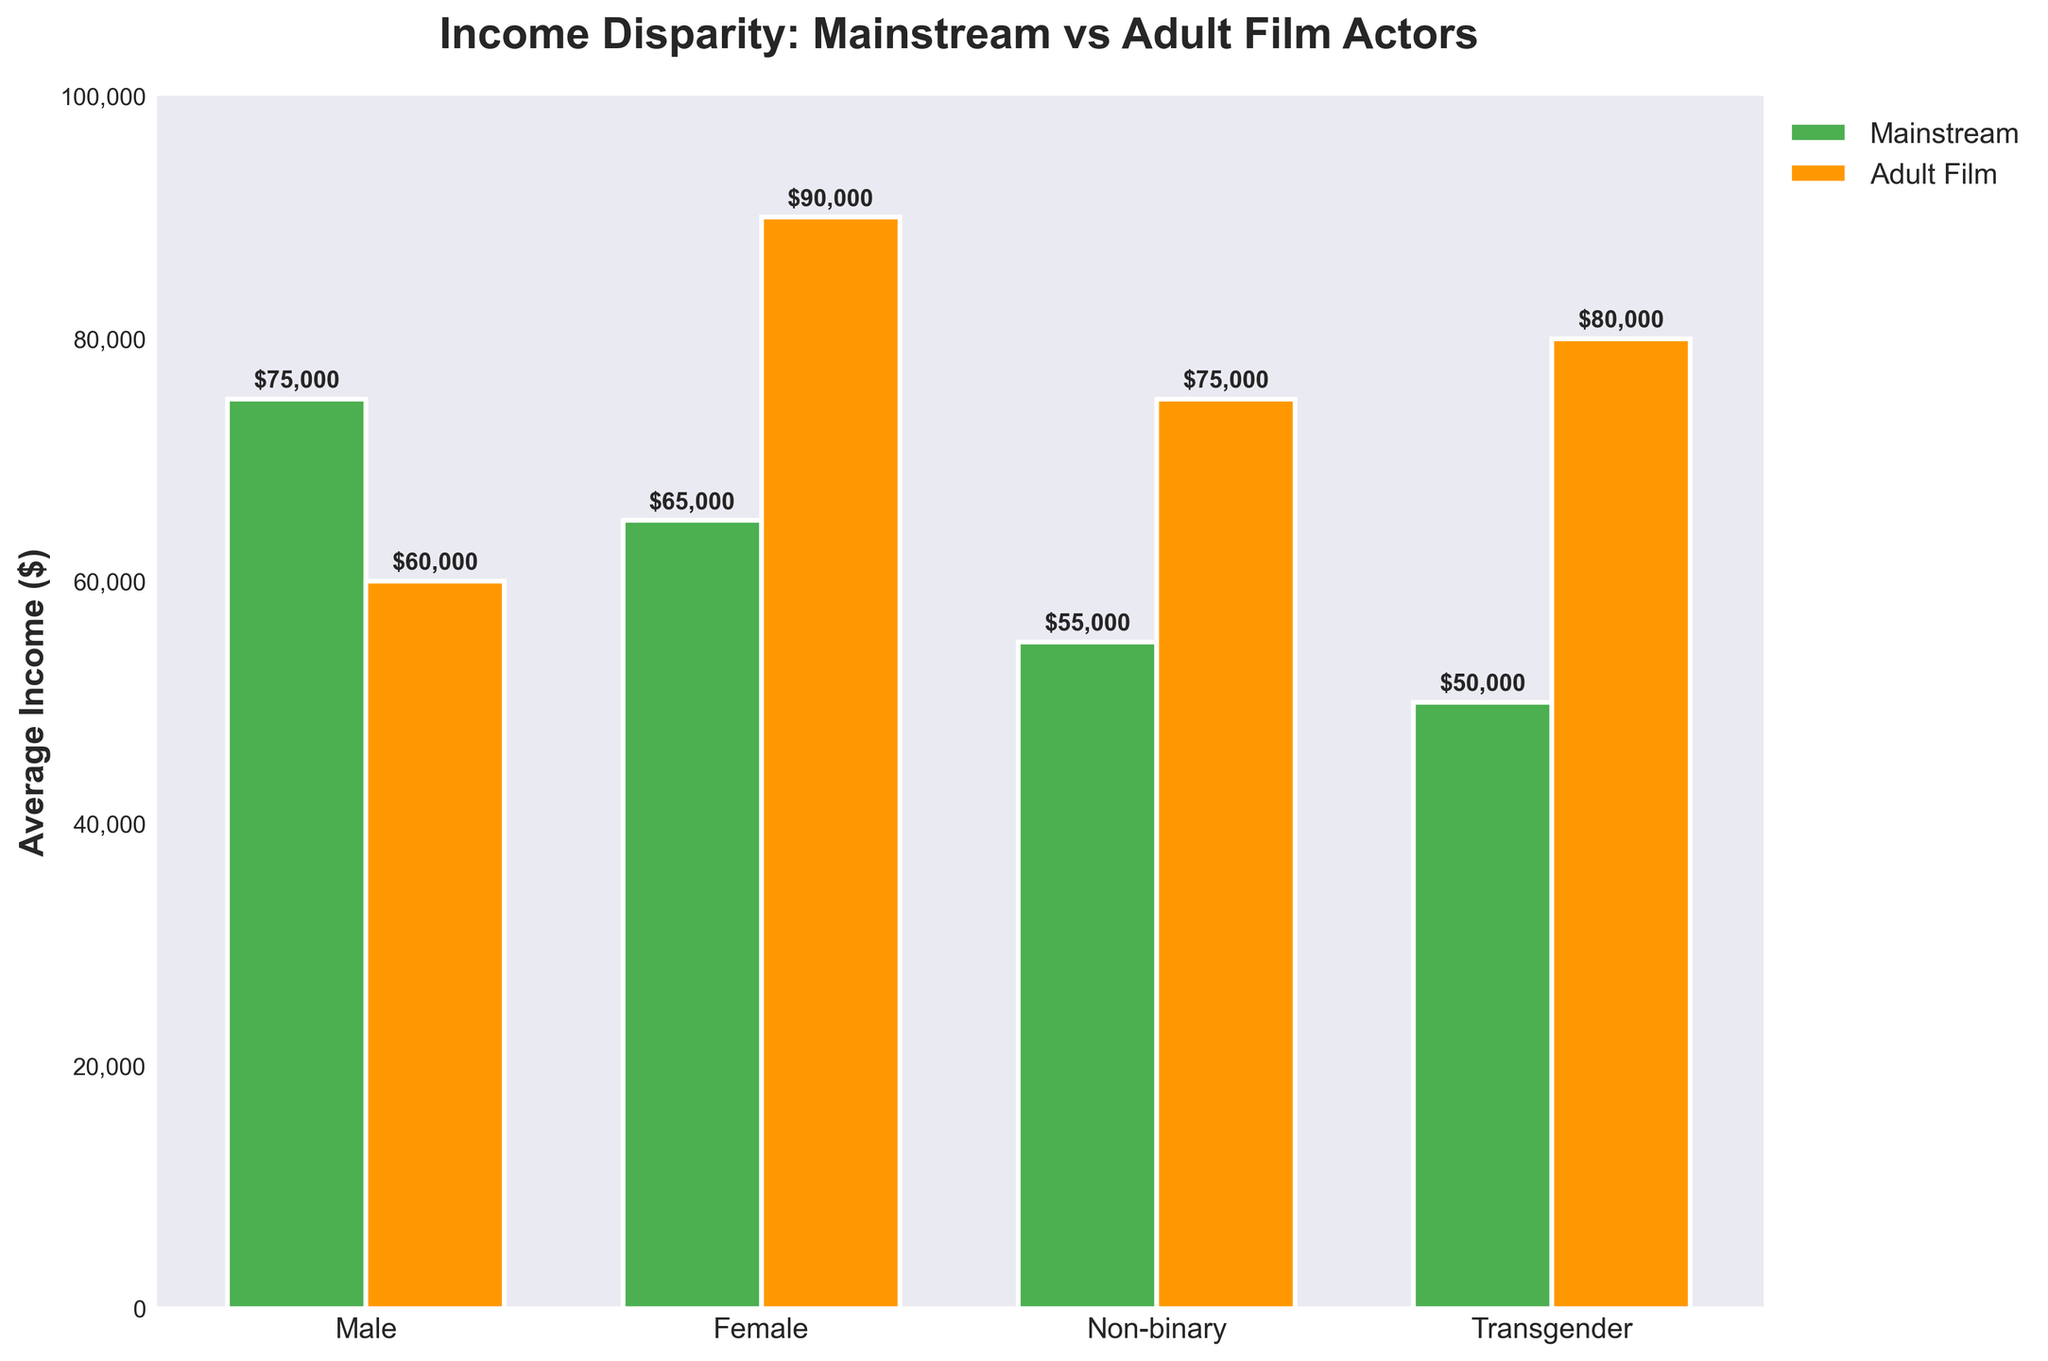What's the average income difference for female actors between mainstream and adult films? To find the average income difference, subtract the average mainstream income for female actors from the average adult film income for female actors: $90,000 - $65,000 = $25,000
Answer: $25,000 Which gender group has the highest average income in the adult film industry? Observing the heights of the orange bars representing adult film incomes, the female actors have the tallest bar at $90,000.
Answer: Female Which gender experiences a higher average income in mainstream films compared to adult films? By comparing the heights of the green and orange bars for each gender, male actors have a higher average income in mainstream films ($75,000) than in adult films ($60,000).
Answer: Male Which gender group shows the largest disparity in average income between mainstream and adult films? Calculate the income disparity for each gender: Male $15,000, Female $25,000, Non-binary $20,000, Transgender $30,000. The largest disparity is for transgender actors.
Answer: Transgender What is the total average income for non-binary actors across both industries? Add the average incomes for non-binary actors in both industries: $55,000 (mainstream) + $75,000 (adult) = $130,000
Answer: $130,000 How much more do transgender actors earn on average in the adult film industry compared to the mainstream industry? Subtract the mainstream average income for transgender actors from the adult film income: $80,000 - $50,000 = $30,000
Answer: $30,000 Compare the average incomes for male and female actors in the mainstream industry. Which is higher and by how much? Subtract the average income of female mainstream actors from male mainstream actors: $75,000 - $65,000 = $10,000. Males earn more by this amount.
Answer: Males, $10,000 How does the average income for non-binary actors in the mainstream industry compare to that of transgender actors in adult films? Compare the bars: Non-binary mainstream income is $55,000 while transgender adult film income is $80,000. Transgender actors in adult films earn $25,000 more on average.
Answer: Transgender adult film, $25,000 more 